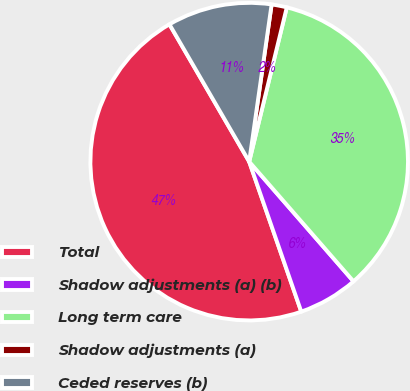<chart> <loc_0><loc_0><loc_500><loc_500><pie_chart><fcel>Total<fcel>Shadow adjustments (a) (b)<fcel>Long term care<fcel>Shadow adjustments (a)<fcel>Ceded reserves (b)<nl><fcel>46.95%<fcel>6.09%<fcel>34.79%<fcel>1.55%<fcel>10.63%<nl></chart> 